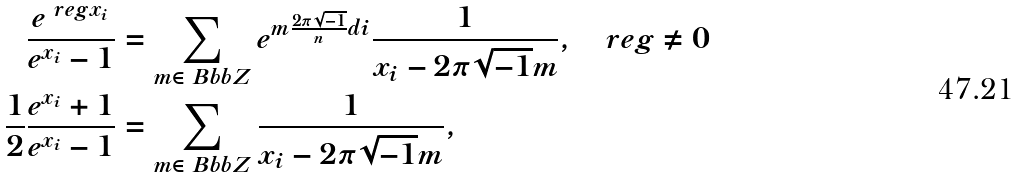Convert formula to latex. <formula><loc_0><loc_0><loc_500><loc_500>\frac { e ^ { \ r e g x _ { i } } } { e ^ { x _ { i } } - 1 } & = \sum _ { m \in { \ B b b Z } } e ^ { m \frac { 2 \pi \sqrt { - 1 } } { n } d i } \frac { 1 } { x _ { i } - 2 \pi \sqrt { - 1 } m } , \quad r e g \ne 0 \\ \frac { 1 } { 2 } \frac { e ^ { x _ { i } } + 1 } { e ^ { x _ { i } } - 1 } & = \sum _ { m \in { \ B b b Z } } \frac { 1 } { x _ { i } - 2 \pi \sqrt { - 1 } m } ,</formula> 